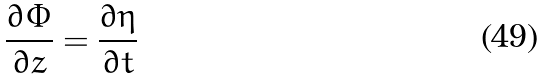Convert formula to latex. <formula><loc_0><loc_0><loc_500><loc_500>\frac { \partial \Phi } { \partial z } = \frac { \partial \eta } { \partial t }</formula> 